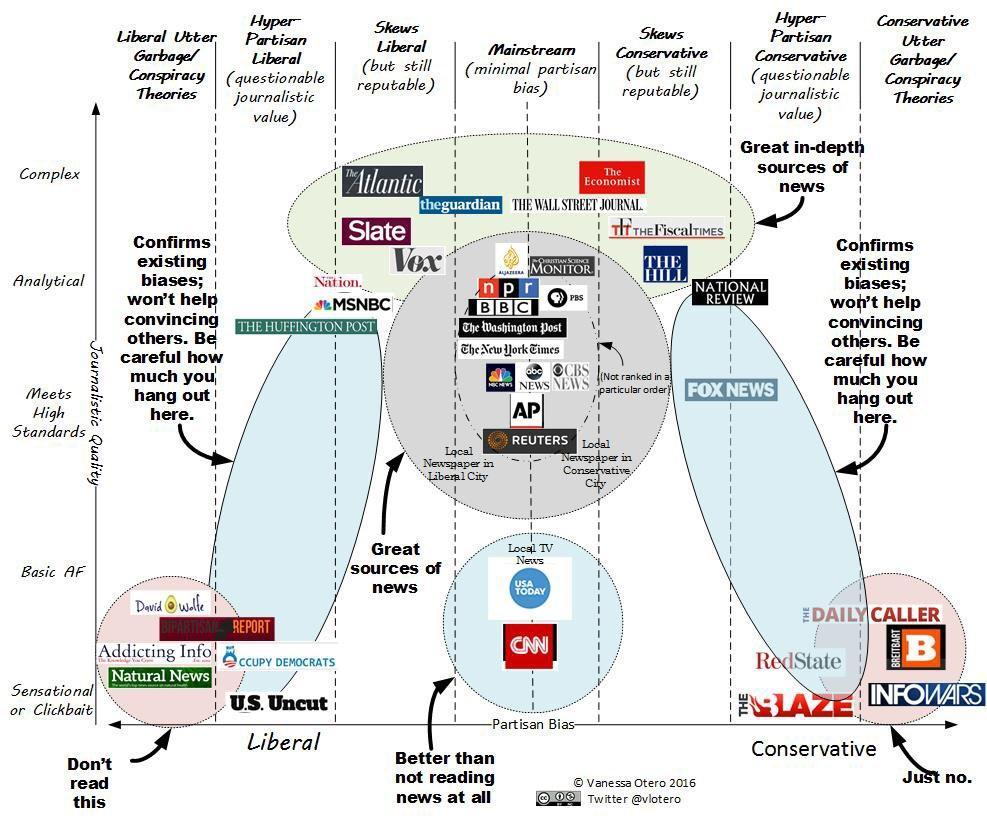which one is lowest quality extreme liberal biased journal?
Answer the question with a short phrase. natural news in how many sections journals are divided based on partisan bias in this infographic? 7 which one is lowest quality extreme conservative biased journal? infowars in which category BBC and Reuters belong? mainstream which has lowest quality in Hyper-partisan liberal category? U. S. Uncut 